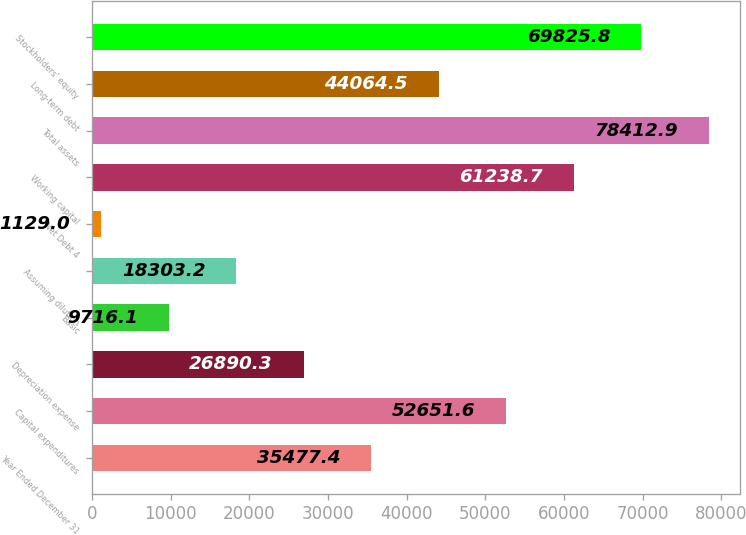Convert chart. <chart><loc_0><loc_0><loc_500><loc_500><bar_chart><fcel>Year Ended December 31<fcel>Capital expenditures<fcel>Depreciation expense<fcel>Basic<fcel>Assuming dilution<fcel>Net Debt 4<fcel>Working capital<fcel>Total assets<fcel>Long-term debt<fcel>Stockholders' equity<nl><fcel>35477.4<fcel>52651.6<fcel>26890.3<fcel>9716.1<fcel>18303.2<fcel>1129<fcel>61238.7<fcel>78412.9<fcel>44064.5<fcel>69825.8<nl></chart> 